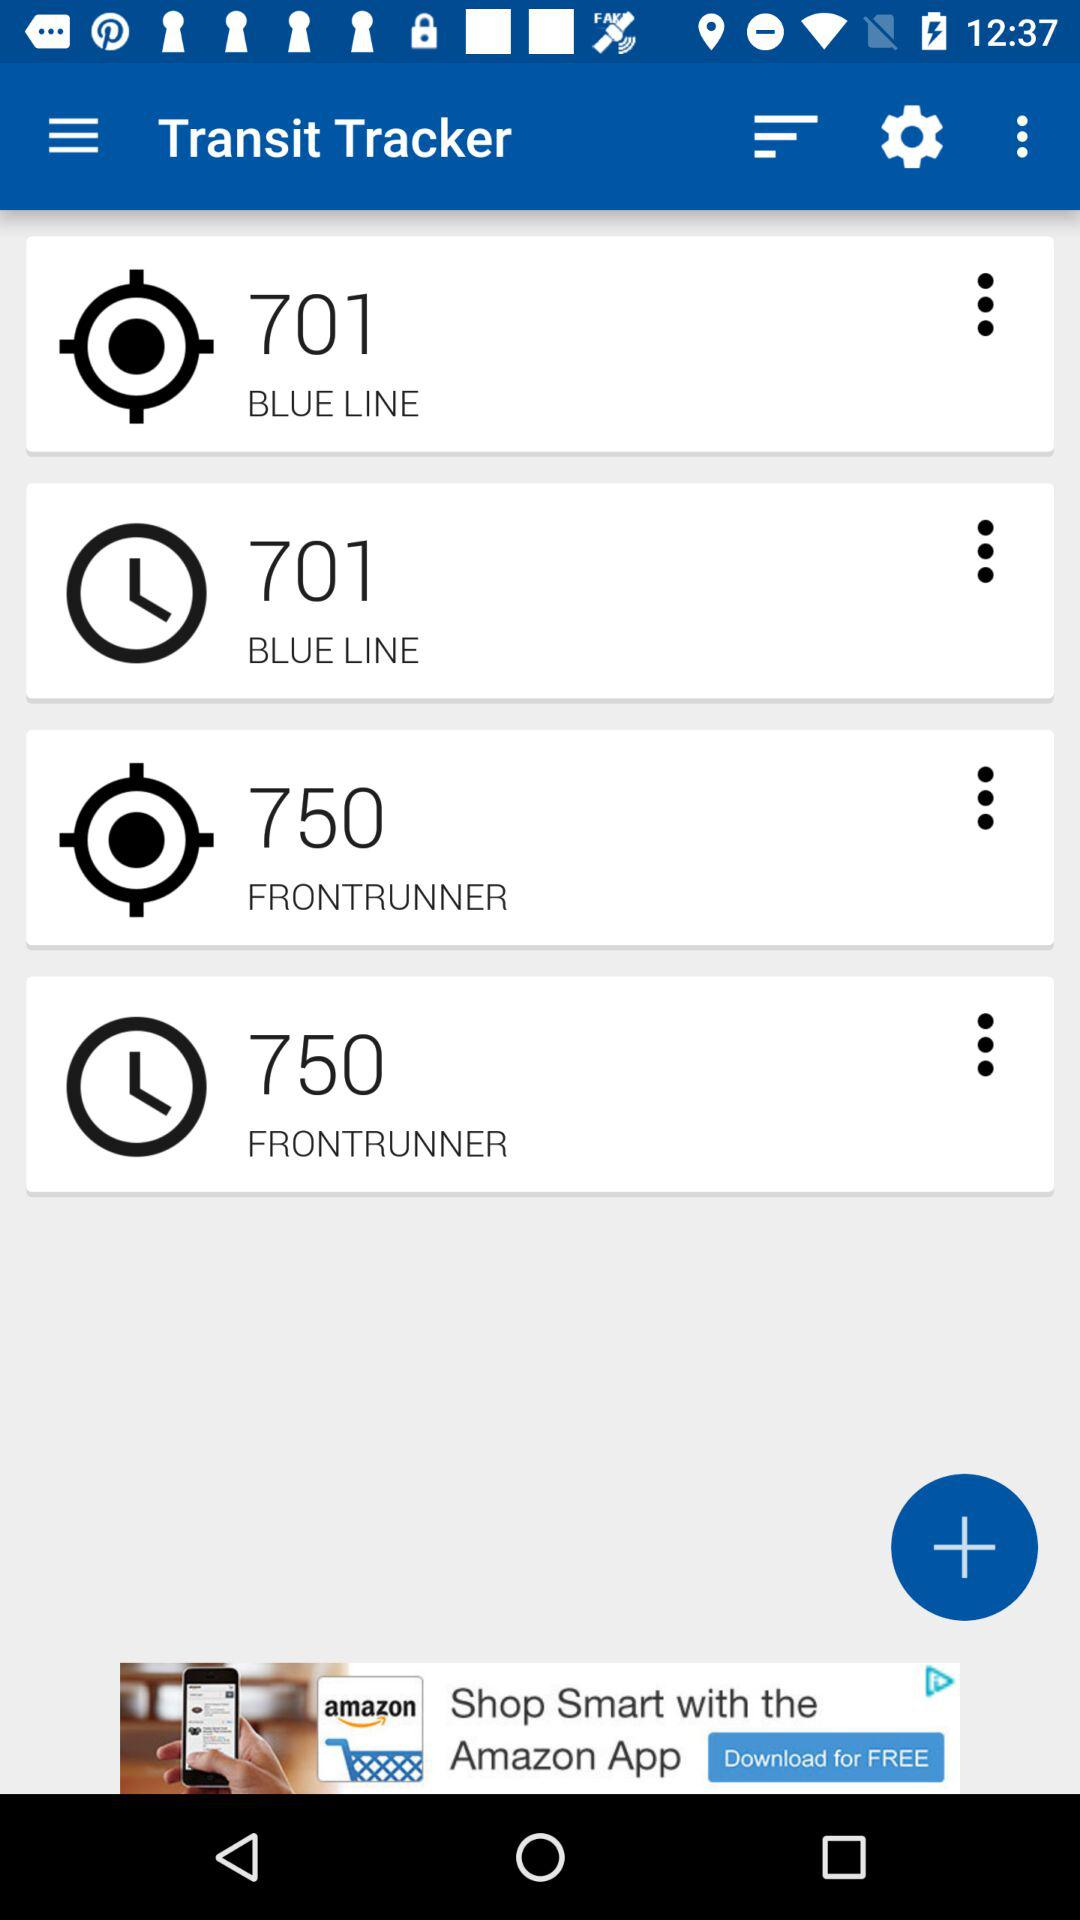What is the application name? The application name is "Transit Tracker". 